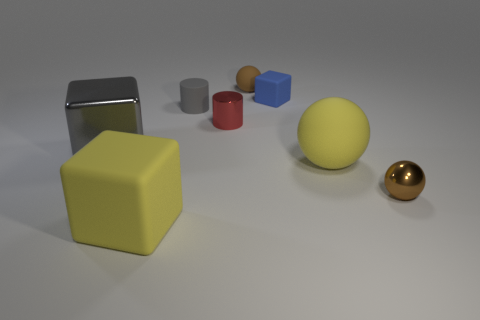What is the shape of the small gray object? cylinder 